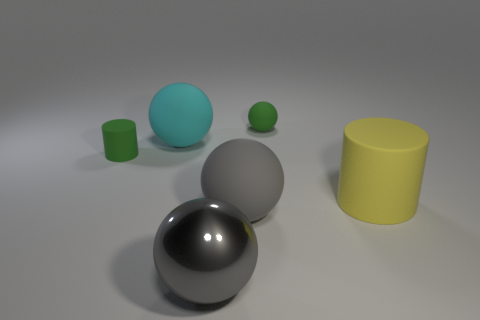Subtract all tiny matte balls. How many balls are left? 3 Subtract all cyan cylinders. How many gray spheres are left? 2 Add 3 small brown shiny cubes. How many objects exist? 9 Subtract all cyan balls. How many balls are left? 3 Subtract all balls. How many objects are left? 2 Subtract all blue spheres. Subtract all red cylinders. How many spheres are left? 4 Add 5 purple metallic balls. How many purple metallic balls exist? 5 Subtract 1 green spheres. How many objects are left? 5 Subtract all yellow matte cylinders. Subtract all big yellow rubber objects. How many objects are left? 4 Add 6 big cyan balls. How many big cyan balls are left? 7 